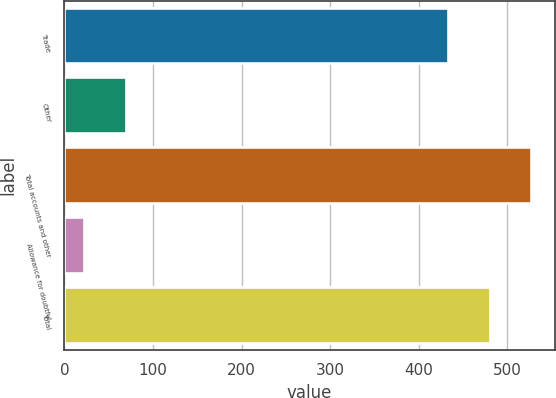Convert chart to OTSL. <chart><loc_0><loc_0><loc_500><loc_500><bar_chart><fcel>Trade<fcel>Other<fcel>Total accounts and other<fcel>Allowance for doubtful<fcel>Total<nl><fcel>433.3<fcel>69.05<fcel>527.2<fcel>22.1<fcel>480.25<nl></chart> 